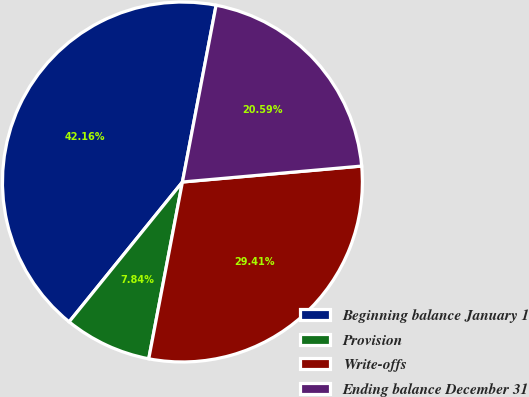Convert chart. <chart><loc_0><loc_0><loc_500><loc_500><pie_chart><fcel>Beginning balance January 1<fcel>Provision<fcel>Write-offs<fcel>Ending balance December 31<nl><fcel>42.16%<fcel>7.84%<fcel>29.41%<fcel>20.59%<nl></chart> 